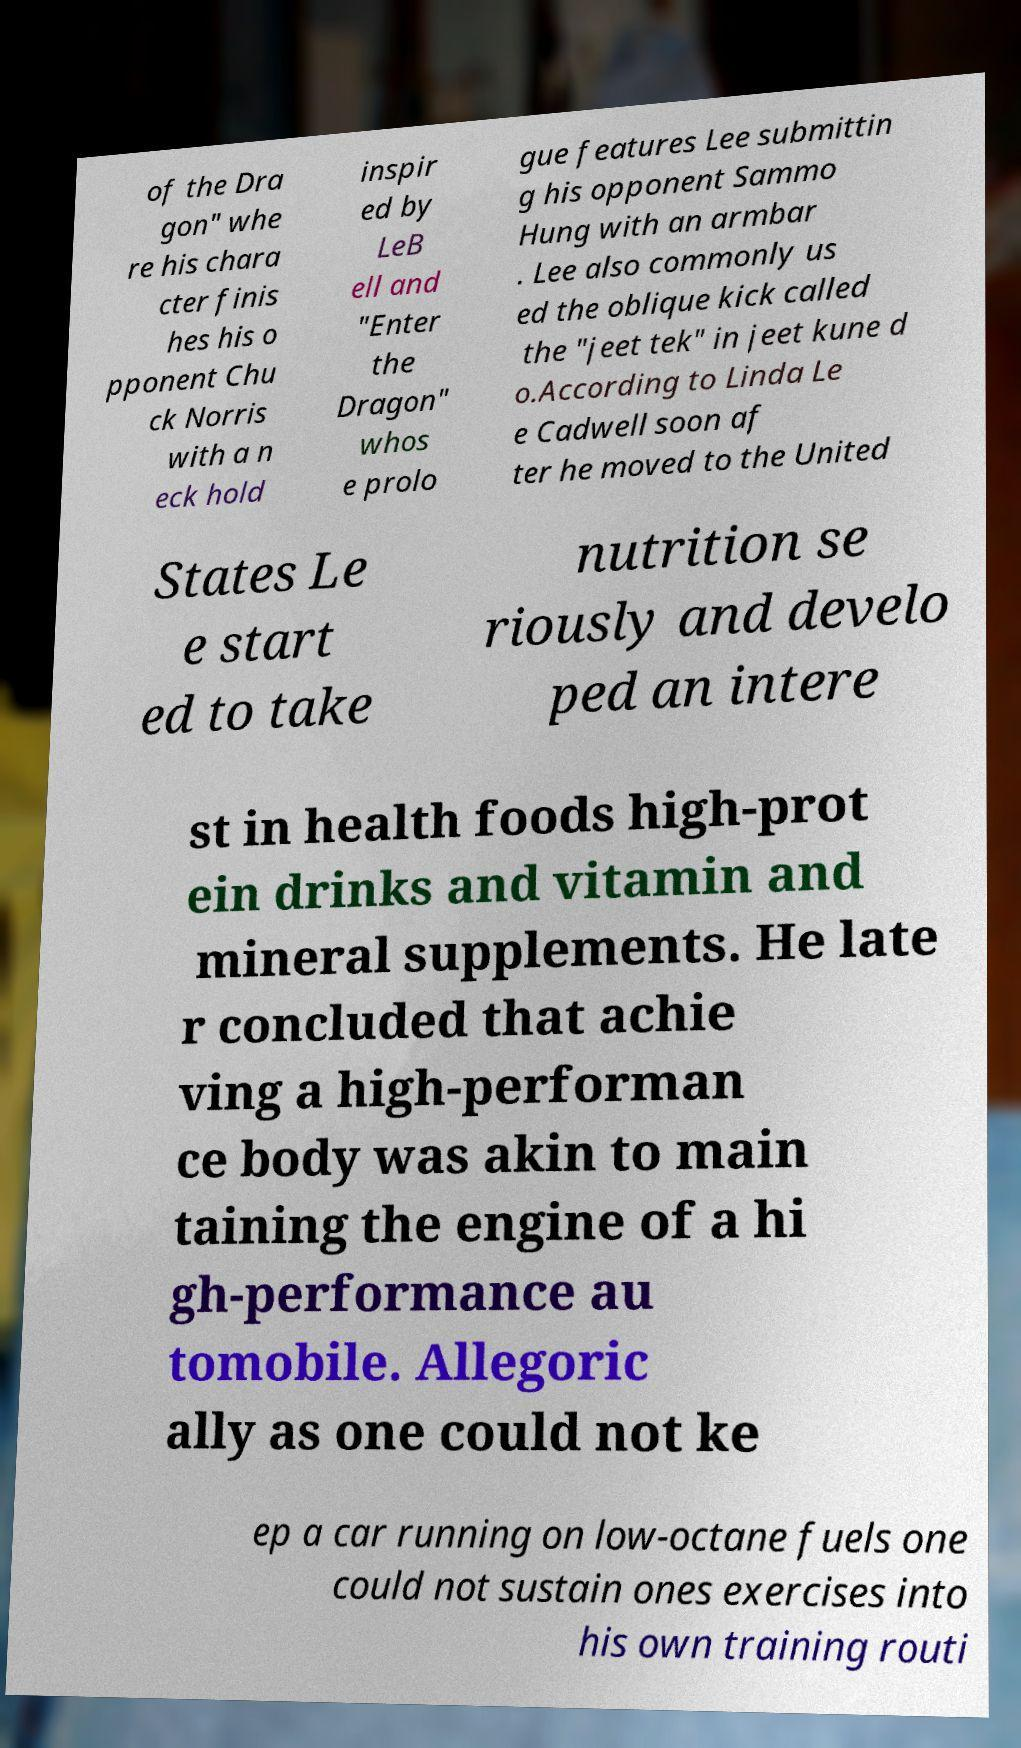Can you accurately transcribe the text from the provided image for me? of the Dra gon" whe re his chara cter finis hes his o pponent Chu ck Norris with a n eck hold inspir ed by LeB ell and "Enter the Dragon" whos e prolo gue features Lee submittin g his opponent Sammo Hung with an armbar . Lee also commonly us ed the oblique kick called the "jeet tek" in jeet kune d o.According to Linda Le e Cadwell soon af ter he moved to the United States Le e start ed to take nutrition se riously and develo ped an intere st in health foods high-prot ein drinks and vitamin and mineral supplements. He late r concluded that achie ving a high-performan ce body was akin to main taining the engine of a hi gh-performance au tomobile. Allegoric ally as one could not ke ep a car running on low-octane fuels one could not sustain ones exercises into his own training routi 